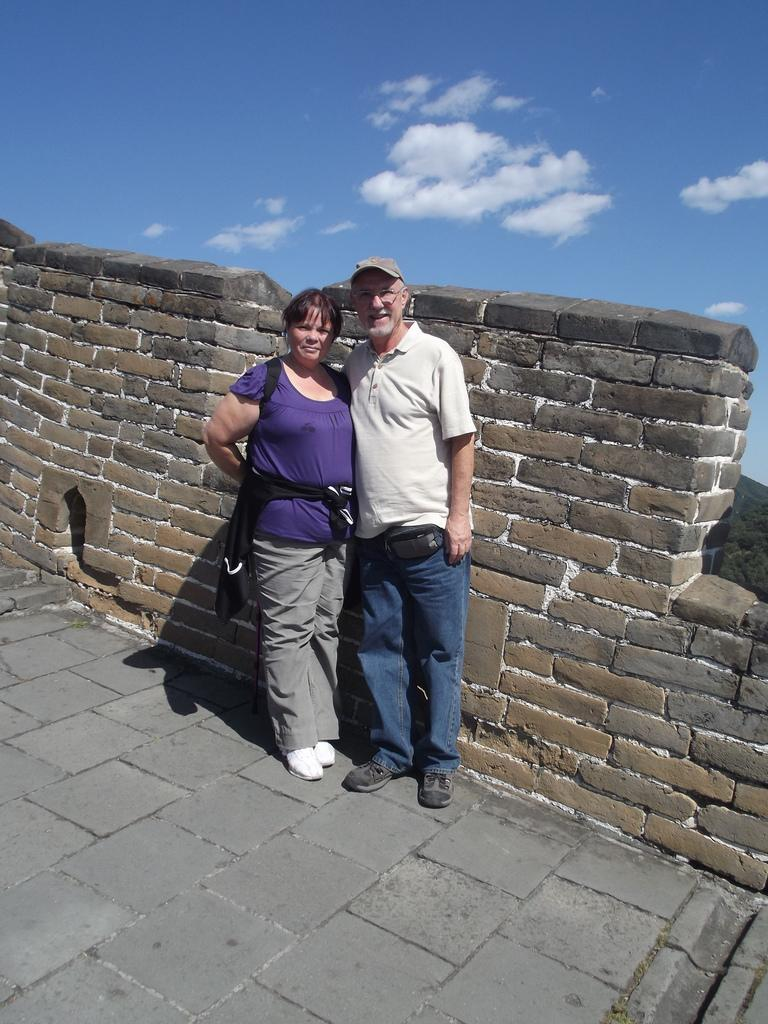How many people are in the image? There are two persons standing in the image. What is one person wearing on their head? One person is wearing a cap. Where are the persons standing? The persons are standing on the ground. What can be seen in the background of the image? There is a wall in the background of the image, and the sky is cloudy. Reasoning: Let'ing: Let's think step by step in order to produce the conversation. We start by identifying the number of people in the image, which is two. Then, we describe one person's clothing, specifically the cap. Next, we mention the location of the persons, which is on the ground. Finally, we describe the background of the image, including the wall and the cloudy sky. Absurd Question/Answer: What type of soda is the person holding in the image? There is no soda present in the image; the persons are not holding any drinks. How many shoes can be seen on the person wearing the cap? The image does not show the person's shoes, so it cannot be determined how many shoes they are wearing. 